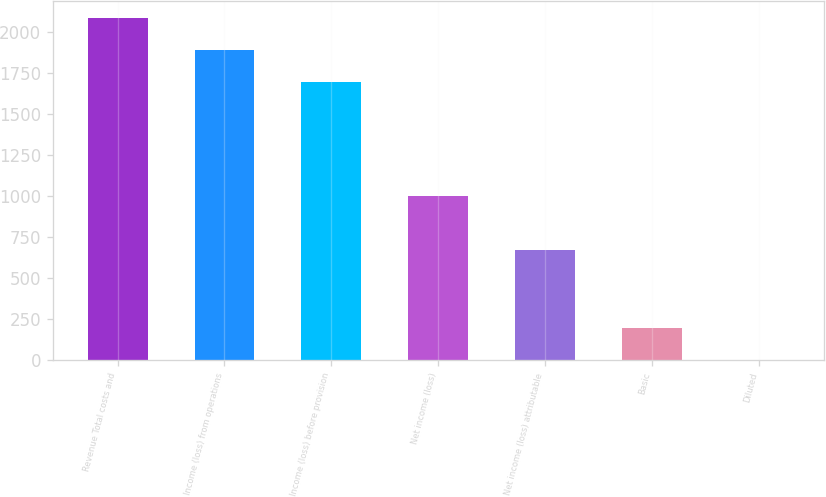<chart> <loc_0><loc_0><loc_500><loc_500><bar_chart><fcel>Revenue Total costs and<fcel>Income (loss) from operations<fcel>Income (loss) before provision<fcel>Net income (loss)<fcel>Net income (loss) attributable<fcel>Basic<fcel>Diluted<nl><fcel>2085.9<fcel>1890.45<fcel>1695<fcel>1000<fcel>668<fcel>195.91<fcel>0.46<nl></chart> 